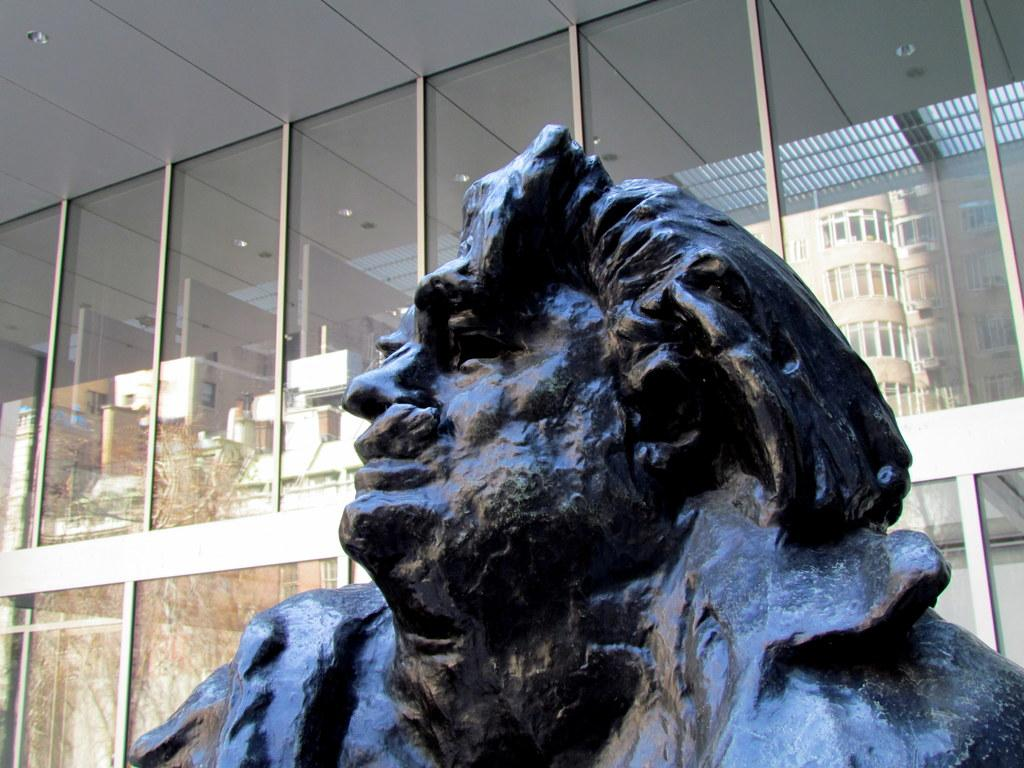What is the main subject in the foreground of the image? There is a sculpture in the foreground of the image. What can be seen in the background of the image? There are glass windows in the background of the image. What do the glass windows reflect? The glass windows reflect buildings and trees. What part of the room is visible at the top of the image? The ceiling is visible at the top of the image. Where is the patch of grass located in the image? There is no patch of grass present in the image. What type of show is being performed in the image? There is no show being performed in the image. 